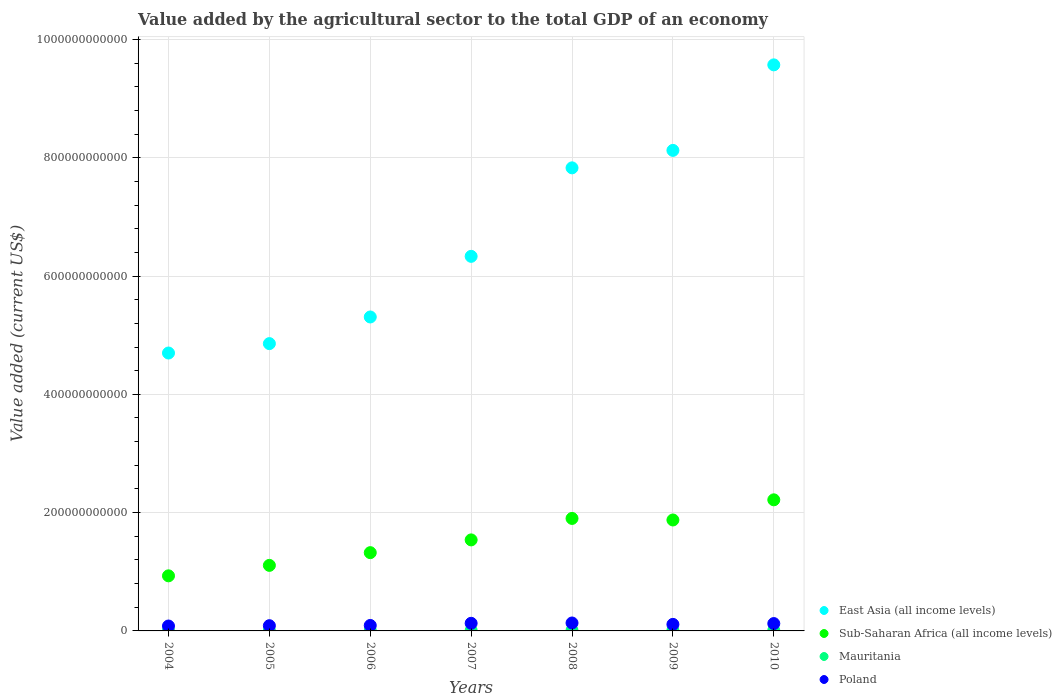Is the number of dotlines equal to the number of legend labels?
Offer a very short reply. Yes. What is the value added by the agricultural sector to the total GDP in Mauritania in 2004?
Give a very brief answer. 5.98e+08. Across all years, what is the maximum value added by the agricultural sector to the total GDP in Sub-Saharan Africa (all income levels)?
Offer a terse response. 2.22e+11. Across all years, what is the minimum value added by the agricultural sector to the total GDP in Mauritania?
Provide a succinct answer. 5.98e+08. In which year was the value added by the agricultural sector to the total GDP in Mauritania minimum?
Offer a terse response. 2004. What is the total value added by the agricultural sector to the total GDP in Sub-Saharan Africa (all income levels) in the graph?
Keep it short and to the point. 1.09e+12. What is the difference between the value added by the agricultural sector to the total GDP in Sub-Saharan Africa (all income levels) in 2008 and that in 2010?
Keep it short and to the point. -3.14e+1. What is the difference between the value added by the agricultural sector to the total GDP in Poland in 2004 and the value added by the agricultural sector to the total GDP in East Asia (all income levels) in 2007?
Provide a short and direct response. -6.25e+11. What is the average value added by the agricultural sector to the total GDP in Poland per year?
Your answer should be compact. 1.09e+1. In the year 2004, what is the difference between the value added by the agricultural sector to the total GDP in Mauritania and value added by the agricultural sector to the total GDP in Poland?
Provide a succinct answer. -7.69e+09. In how many years, is the value added by the agricultural sector to the total GDP in Sub-Saharan Africa (all income levels) greater than 240000000000 US$?
Provide a succinct answer. 0. What is the ratio of the value added by the agricultural sector to the total GDP in Mauritania in 2007 to that in 2010?
Your answer should be very brief. 0.9. Is the difference between the value added by the agricultural sector to the total GDP in Mauritania in 2005 and 2009 greater than the difference between the value added by the agricultural sector to the total GDP in Poland in 2005 and 2009?
Offer a very short reply. Yes. What is the difference between the highest and the second highest value added by the agricultural sector to the total GDP in East Asia (all income levels)?
Keep it short and to the point. 1.45e+11. What is the difference between the highest and the lowest value added by the agricultural sector to the total GDP in Poland?
Give a very brief answer. 5.12e+09. In how many years, is the value added by the agricultural sector to the total GDP in Poland greater than the average value added by the agricultural sector to the total GDP in Poland taken over all years?
Keep it short and to the point. 4. Is the sum of the value added by the agricultural sector to the total GDP in Mauritania in 2005 and 2006 greater than the maximum value added by the agricultural sector to the total GDP in Sub-Saharan Africa (all income levels) across all years?
Your response must be concise. No. Does the value added by the agricultural sector to the total GDP in Mauritania monotonically increase over the years?
Your answer should be compact. No. How many years are there in the graph?
Your answer should be compact. 7. What is the difference between two consecutive major ticks on the Y-axis?
Offer a very short reply. 2.00e+11. Does the graph contain any zero values?
Provide a succinct answer. No. Does the graph contain grids?
Your answer should be very brief. Yes. Where does the legend appear in the graph?
Ensure brevity in your answer.  Bottom right. How many legend labels are there?
Your answer should be compact. 4. How are the legend labels stacked?
Make the answer very short. Vertical. What is the title of the graph?
Your answer should be very brief. Value added by the agricultural sector to the total GDP of an economy. What is the label or title of the X-axis?
Your answer should be compact. Years. What is the label or title of the Y-axis?
Your answer should be very brief. Value added (current US$). What is the Value added (current US$) of East Asia (all income levels) in 2004?
Your response must be concise. 4.70e+11. What is the Value added (current US$) in Sub-Saharan Africa (all income levels) in 2004?
Make the answer very short. 9.31e+1. What is the Value added (current US$) in Mauritania in 2004?
Your answer should be compact. 5.98e+08. What is the Value added (current US$) in Poland in 2004?
Provide a succinct answer. 8.29e+09. What is the Value added (current US$) in East Asia (all income levels) in 2005?
Provide a short and direct response. 4.86e+11. What is the Value added (current US$) in Sub-Saharan Africa (all income levels) in 2005?
Offer a terse response. 1.11e+11. What is the Value added (current US$) in Mauritania in 2005?
Your answer should be compact. 6.15e+08. What is the Value added (current US$) of Poland in 2005?
Your response must be concise. 8.85e+09. What is the Value added (current US$) in East Asia (all income levels) in 2006?
Provide a succinct answer. 5.31e+11. What is the Value added (current US$) of Sub-Saharan Africa (all income levels) in 2006?
Your answer should be compact. 1.32e+11. What is the Value added (current US$) in Mauritania in 2006?
Provide a succinct answer. 6.51e+08. What is the Value added (current US$) in Poland in 2006?
Ensure brevity in your answer.  9.23e+09. What is the Value added (current US$) in East Asia (all income levels) in 2007?
Your answer should be compact. 6.33e+11. What is the Value added (current US$) in Sub-Saharan Africa (all income levels) in 2007?
Your response must be concise. 1.54e+11. What is the Value added (current US$) in Mauritania in 2007?
Your answer should be very brief. 7.93e+08. What is the Value added (current US$) in Poland in 2007?
Offer a very short reply. 1.29e+1. What is the Value added (current US$) in East Asia (all income levels) in 2008?
Give a very brief answer. 7.83e+11. What is the Value added (current US$) of Sub-Saharan Africa (all income levels) in 2008?
Offer a terse response. 1.90e+11. What is the Value added (current US$) of Mauritania in 2008?
Your answer should be compact. 9.45e+08. What is the Value added (current US$) of Poland in 2008?
Keep it short and to the point. 1.34e+1. What is the Value added (current US$) of East Asia (all income levels) in 2009?
Keep it short and to the point. 8.12e+11. What is the Value added (current US$) of Sub-Saharan Africa (all income levels) in 2009?
Ensure brevity in your answer.  1.88e+11. What is the Value added (current US$) of Mauritania in 2009?
Your response must be concise. 8.83e+08. What is the Value added (current US$) of Poland in 2009?
Offer a very short reply. 1.11e+1. What is the Value added (current US$) of East Asia (all income levels) in 2010?
Give a very brief answer. 9.57e+11. What is the Value added (current US$) of Sub-Saharan Africa (all income levels) in 2010?
Keep it short and to the point. 2.22e+11. What is the Value added (current US$) of Mauritania in 2010?
Your answer should be compact. 8.80e+08. What is the Value added (current US$) of Poland in 2010?
Offer a terse response. 1.24e+1. Across all years, what is the maximum Value added (current US$) in East Asia (all income levels)?
Give a very brief answer. 9.57e+11. Across all years, what is the maximum Value added (current US$) of Sub-Saharan Africa (all income levels)?
Give a very brief answer. 2.22e+11. Across all years, what is the maximum Value added (current US$) in Mauritania?
Give a very brief answer. 9.45e+08. Across all years, what is the maximum Value added (current US$) of Poland?
Give a very brief answer. 1.34e+1. Across all years, what is the minimum Value added (current US$) in East Asia (all income levels)?
Make the answer very short. 4.70e+11. Across all years, what is the minimum Value added (current US$) of Sub-Saharan Africa (all income levels)?
Your response must be concise. 9.31e+1. Across all years, what is the minimum Value added (current US$) in Mauritania?
Offer a very short reply. 5.98e+08. Across all years, what is the minimum Value added (current US$) of Poland?
Give a very brief answer. 8.29e+09. What is the total Value added (current US$) in East Asia (all income levels) in the graph?
Offer a terse response. 4.67e+12. What is the total Value added (current US$) in Sub-Saharan Africa (all income levels) in the graph?
Your answer should be compact. 1.09e+12. What is the total Value added (current US$) of Mauritania in the graph?
Make the answer very short. 5.37e+09. What is the total Value added (current US$) in Poland in the graph?
Make the answer very short. 7.62e+1. What is the difference between the Value added (current US$) in East Asia (all income levels) in 2004 and that in 2005?
Make the answer very short. -1.59e+1. What is the difference between the Value added (current US$) of Sub-Saharan Africa (all income levels) in 2004 and that in 2005?
Make the answer very short. -1.77e+1. What is the difference between the Value added (current US$) in Mauritania in 2004 and that in 2005?
Your response must be concise. -1.72e+07. What is the difference between the Value added (current US$) of Poland in 2004 and that in 2005?
Offer a terse response. -5.58e+08. What is the difference between the Value added (current US$) of East Asia (all income levels) in 2004 and that in 2006?
Provide a succinct answer. -6.09e+1. What is the difference between the Value added (current US$) of Sub-Saharan Africa (all income levels) in 2004 and that in 2006?
Provide a short and direct response. -3.92e+1. What is the difference between the Value added (current US$) in Mauritania in 2004 and that in 2006?
Your answer should be very brief. -5.31e+07. What is the difference between the Value added (current US$) in Poland in 2004 and that in 2006?
Give a very brief answer. -9.44e+08. What is the difference between the Value added (current US$) of East Asia (all income levels) in 2004 and that in 2007?
Your answer should be compact. -1.63e+11. What is the difference between the Value added (current US$) in Sub-Saharan Africa (all income levels) in 2004 and that in 2007?
Your response must be concise. -6.08e+1. What is the difference between the Value added (current US$) in Mauritania in 2004 and that in 2007?
Keep it short and to the point. -1.95e+08. What is the difference between the Value added (current US$) in Poland in 2004 and that in 2007?
Provide a short and direct response. -4.59e+09. What is the difference between the Value added (current US$) in East Asia (all income levels) in 2004 and that in 2008?
Your response must be concise. -3.13e+11. What is the difference between the Value added (current US$) of Sub-Saharan Africa (all income levels) in 2004 and that in 2008?
Ensure brevity in your answer.  -9.71e+1. What is the difference between the Value added (current US$) in Mauritania in 2004 and that in 2008?
Your response must be concise. -3.47e+08. What is the difference between the Value added (current US$) of Poland in 2004 and that in 2008?
Provide a short and direct response. -5.12e+09. What is the difference between the Value added (current US$) of East Asia (all income levels) in 2004 and that in 2009?
Your answer should be very brief. -3.43e+11. What is the difference between the Value added (current US$) of Sub-Saharan Africa (all income levels) in 2004 and that in 2009?
Keep it short and to the point. -9.44e+1. What is the difference between the Value added (current US$) of Mauritania in 2004 and that in 2009?
Give a very brief answer. -2.85e+08. What is the difference between the Value added (current US$) of Poland in 2004 and that in 2009?
Your answer should be compact. -2.77e+09. What is the difference between the Value added (current US$) in East Asia (all income levels) in 2004 and that in 2010?
Make the answer very short. -4.87e+11. What is the difference between the Value added (current US$) in Sub-Saharan Africa (all income levels) in 2004 and that in 2010?
Your answer should be compact. -1.29e+11. What is the difference between the Value added (current US$) of Mauritania in 2004 and that in 2010?
Your response must be concise. -2.82e+08. What is the difference between the Value added (current US$) of Poland in 2004 and that in 2010?
Offer a very short reply. -4.15e+09. What is the difference between the Value added (current US$) in East Asia (all income levels) in 2005 and that in 2006?
Make the answer very short. -4.50e+1. What is the difference between the Value added (current US$) in Sub-Saharan Africa (all income levels) in 2005 and that in 2006?
Your answer should be compact. -2.15e+1. What is the difference between the Value added (current US$) in Mauritania in 2005 and that in 2006?
Make the answer very short. -3.58e+07. What is the difference between the Value added (current US$) of Poland in 2005 and that in 2006?
Make the answer very short. -3.87e+08. What is the difference between the Value added (current US$) in East Asia (all income levels) in 2005 and that in 2007?
Keep it short and to the point. -1.48e+11. What is the difference between the Value added (current US$) in Sub-Saharan Africa (all income levels) in 2005 and that in 2007?
Give a very brief answer. -4.31e+1. What is the difference between the Value added (current US$) in Mauritania in 2005 and that in 2007?
Keep it short and to the point. -1.77e+08. What is the difference between the Value added (current US$) of Poland in 2005 and that in 2007?
Offer a terse response. -4.04e+09. What is the difference between the Value added (current US$) in East Asia (all income levels) in 2005 and that in 2008?
Offer a very short reply. -2.97e+11. What is the difference between the Value added (current US$) in Sub-Saharan Africa (all income levels) in 2005 and that in 2008?
Provide a succinct answer. -7.94e+1. What is the difference between the Value added (current US$) of Mauritania in 2005 and that in 2008?
Offer a terse response. -3.29e+08. What is the difference between the Value added (current US$) in Poland in 2005 and that in 2008?
Ensure brevity in your answer.  -4.56e+09. What is the difference between the Value added (current US$) in East Asia (all income levels) in 2005 and that in 2009?
Keep it short and to the point. -3.27e+11. What is the difference between the Value added (current US$) of Sub-Saharan Africa (all income levels) in 2005 and that in 2009?
Your response must be concise. -7.68e+1. What is the difference between the Value added (current US$) in Mauritania in 2005 and that in 2009?
Ensure brevity in your answer.  -2.68e+08. What is the difference between the Value added (current US$) in Poland in 2005 and that in 2009?
Your answer should be compact. -2.21e+09. What is the difference between the Value added (current US$) of East Asia (all income levels) in 2005 and that in 2010?
Your answer should be very brief. -4.71e+11. What is the difference between the Value added (current US$) of Sub-Saharan Africa (all income levels) in 2005 and that in 2010?
Offer a terse response. -1.11e+11. What is the difference between the Value added (current US$) in Mauritania in 2005 and that in 2010?
Your response must be concise. -2.65e+08. What is the difference between the Value added (current US$) in Poland in 2005 and that in 2010?
Provide a short and direct response. -3.60e+09. What is the difference between the Value added (current US$) in East Asia (all income levels) in 2006 and that in 2007?
Offer a terse response. -1.03e+11. What is the difference between the Value added (current US$) in Sub-Saharan Africa (all income levels) in 2006 and that in 2007?
Ensure brevity in your answer.  -2.16e+1. What is the difference between the Value added (current US$) of Mauritania in 2006 and that in 2007?
Offer a terse response. -1.42e+08. What is the difference between the Value added (current US$) of Poland in 2006 and that in 2007?
Keep it short and to the point. -3.65e+09. What is the difference between the Value added (current US$) of East Asia (all income levels) in 2006 and that in 2008?
Your response must be concise. -2.52e+11. What is the difference between the Value added (current US$) of Sub-Saharan Africa (all income levels) in 2006 and that in 2008?
Provide a short and direct response. -5.79e+1. What is the difference between the Value added (current US$) of Mauritania in 2006 and that in 2008?
Offer a very short reply. -2.94e+08. What is the difference between the Value added (current US$) in Poland in 2006 and that in 2008?
Offer a terse response. -4.17e+09. What is the difference between the Value added (current US$) of East Asia (all income levels) in 2006 and that in 2009?
Provide a short and direct response. -2.82e+11. What is the difference between the Value added (current US$) in Sub-Saharan Africa (all income levels) in 2006 and that in 2009?
Provide a short and direct response. -5.52e+1. What is the difference between the Value added (current US$) in Mauritania in 2006 and that in 2009?
Offer a very short reply. -2.32e+08. What is the difference between the Value added (current US$) in Poland in 2006 and that in 2009?
Provide a succinct answer. -1.83e+09. What is the difference between the Value added (current US$) of East Asia (all income levels) in 2006 and that in 2010?
Offer a terse response. -4.26e+11. What is the difference between the Value added (current US$) in Sub-Saharan Africa (all income levels) in 2006 and that in 2010?
Offer a very short reply. -8.93e+1. What is the difference between the Value added (current US$) in Mauritania in 2006 and that in 2010?
Provide a succinct answer. -2.29e+08. What is the difference between the Value added (current US$) in Poland in 2006 and that in 2010?
Make the answer very short. -3.21e+09. What is the difference between the Value added (current US$) in East Asia (all income levels) in 2007 and that in 2008?
Offer a terse response. -1.50e+11. What is the difference between the Value added (current US$) of Sub-Saharan Africa (all income levels) in 2007 and that in 2008?
Offer a very short reply. -3.63e+1. What is the difference between the Value added (current US$) of Mauritania in 2007 and that in 2008?
Your answer should be compact. -1.52e+08. What is the difference between the Value added (current US$) of Poland in 2007 and that in 2008?
Provide a succinct answer. -5.25e+08. What is the difference between the Value added (current US$) in East Asia (all income levels) in 2007 and that in 2009?
Ensure brevity in your answer.  -1.79e+11. What is the difference between the Value added (current US$) of Sub-Saharan Africa (all income levels) in 2007 and that in 2009?
Offer a very short reply. -3.37e+1. What is the difference between the Value added (current US$) in Mauritania in 2007 and that in 2009?
Provide a short and direct response. -9.02e+07. What is the difference between the Value added (current US$) of Poland in 2007 and that in 2009?
Your response must be concise. 1.82e+09. What is the difference between the Value added (current US$) in East Asia (all income levels) in 2007 and that in 2010?
Keep it short and to the point. -3.24e+11. What is the difference between the Value added (current US$) of Sub-Saharan Africa (all income levels) in 2007 and that in 2010?
Your response must be concise. -6.77e+1. What is the difference between the Value added (current US$) in Mauritania in 2007 and that in 2010?
Offer a very short reply. -8.75e+07. What is the difference between the Value added (current US$) in Poland in 2007 and that in 2010?
Make the answer very short. 4.42e+08. What is the difference between the Value added (current US$) in East Asia (all income levels) in 2008 and that in 2009?
Ensure brevity in your answer.  -2.95e+1. What is the difference between the Value added (current US$) in Sub-Saharan Africa (all income levels) in 2008 and that in 2009?
Keep it short and to the point. 2.62e+09. What is the difference between the Value added (current US$) in Mauritania in 2008 and that in 2009?
Offer a terse response. 6.18e+07. What is the difference between the Value added (current US$) of Poland in 2008 and that in 2009?
Provide a short and direct response. 2.35e+09. What is the difference between the Value added (current US$) in East Asia (all income levels) in 2008 and that in 2010?
Keep it short and to the point. -1.74e+11. What is the difference between the Value added (current US$) in Sub-Saharan Africa (all income levels) in 2008 and that in 2010?
Provide a succinct answer. -3.14e+1. What is the difference between the Value added (current US$) in Mauritania in 2008 and that in 2010?
Offer a very short reply. 6.45e+07. What is the difference between the Value added (current US$) of Poland in 2008 and that in 2010?
Give a very brief answer. 9.66e+08. What is the difference between the Value added (current US$) of East Asia (all income levels) in 2009 and that in 2010?
Your response must be concise. -1.45e+11. What is the difference between the Value added (current US$) of Sub-Saharan Africa (all income levels) in 2009 and that in 2010?
Your answer should be compact. -3.41e+1. What is the difference between the Value added (current US$) in Mauritania in 2009 and that in 2010?
Your answer should be very brief. 2.76e+06. What is the difference between the Value added (current US$) of Poland in 2009 and that in 2010?
Offer a very short reply. -1.38e+09. What is the difference between the Value added (current US$) in East Asia (all income levels) in 2004 and the Value added (current US$) in Sub-Saharan Africa (all income levels) in 2005?
Offer a very short reply. 3.59e+11. What is the difference between the Value added (current US$) in East Asia (all income levels) in 2004 and the Value added (current US$) in Mauritania in 2005?
Offer a very short reply. 4.69e+11. What is the difference between the Value added (current US$) of East Asia (all income levels) in 2004 and the Value added (current US$) of Poland in 2005?
Make the answer very short. 4.61e+11. What is the difference between the Value added (current US$) of Sub-Saharan Africa (all income levels) in 2004 and the Value added (current US$) of Mauritania in 2005?
Provide a succinct answer. 9.25e+1. What is the difference between the Value added (current US$) in Sub-Saharan Africa (all income levels) in 2004 and the Value added (current US$) in Poland in 2005?
Offer a very short reply. 8.43e+1. What is the difference between the Value added (current US$) of Mauritania in 2004 and the Value added (current US$) of Poland in 2005?
Offer a very short reply. -8.25e+09. What is the difference between the Value added (current US$) in East Asia (all income levels) in 2004 and the Value added (current US$) in Sub-Saharan Africa (all income levels) in 2006?
Offer a very short reply. 3.38e+11. What is the difference between the Value added (current US$) of East Asia (all income levels) in 2004 and the Value added (current US$) of Mauritania in 2006?
Make the answer very short. 4.69e+11. What is the difference between the Value added (current US$) of East Asia (all income levels) in 2004 and the Value added (current US$) of Poland in 2006?
Your answer should be compact. 4.61e+11. What is the difference between the Value added (current US$) of Sub-Saharan Africa (all income levels) in 2004 and the Value added (current US$) of Mauritania in 2006?
Your answer should be very brief. 9.25e+1. What is the difference between the Value added (current US$) in Sub-Saharan Africa (all income levels) in 2004 and the Value added (current US$) in Poland in 2006?
Give a very brief answer. 8.39e+1. What is the difference between the Value added (current US$) in Mauritania in 2004 and the Value added (current US$) in Poland in 2006?
Your answer should be compact. -8.64e+09. What is the difference between the Value added (current US$) in East Asia (all income levels) in 2004 and the Value added (current US$) in Sub-Saharan Africa (all income levels) in 2007?
Provide a succinct answer. 3.16e+11. What is the difference between the Value added (current US$) of East Asia (all income levels) in 2004 and the Value added (current US$) of Mauritania in 2007?
Offer a terse response. 4.69e+11. What is the difference between the Value added (current US$) of East Asia (all income levels) in 2004 and the Value added (current US$) of Poland in 2007?
Offer a terse response. 4.57e+11. What is the difference between the Value added (current US$) of Sub-Saharan Africa (all income levels) in 2004 and the Value added (current US$) of Mauritania in 2007?
Your response must be concise. 9.23e+1. What is the difference between the Value added (current US$) of Sub-Saharan Africa (all income levels) in 2004 and the Value added (current US$) of Poland in 2007?
Your answer should be compact. 8.03e+1. What is the difference between the Value added (current US$) of Mauritania in 2004 and the Value added (current US$) of Poland in 2007?
Provide a short and direct response. -1.23e+1. What is the difference between the Value added (current US$) in East Asia (all income levels) in 2004 and the Value added (current US$) in Sub-Saharan Africa (all income levels) in 2008?
Your answer should be very brief. 2.80e+11. What is the difference between the Value added (current US$) in East Asia (all income levels) in 2004 and the Value added (current US$) in Mauritania in 2008?
Your answer should be compact. 4.69e+11. What is the difference between the Value added (current US$) in East Asia (all income levels) in 2004 and the Value added (current US$) in Poland in 2008?
Your answer should be very brief. 4.56e+11. What is the difference between the Value added (current US$) in Sub-Saharan Africa (all income levels) in 2004 and the Value added (current US$) in Mauritania in 2008?
Provide a succinct answer. 9.22e+1. What is the difference between the Value added (current US$) of Sub-Saharan Africa (all income levels) in 2004 and the Value added (current US$) of Poland in 2008?
Make the answer very short. 7.97e+1. What is the difference between the Value added (current US$) of Mauritania in 2004 and the Value added (current US$) of Poland in 2008?
Your answer should be compact. -1.28e+1. What is the difference between the Value added (current US$) of East Asia (all income levels) in 2004 and the Value added (current US$) of Sub-Saharan Africa (all income levels) in 2009?
Provide a short and direct response. 2.82e+11. What is the difference between the Value added (current US$) of East Asia (all income levels) in 2004 and the Value added (current US$) of Mauritania in 2009?
Your answer should be very brief. 4.69e+11. What is the difference between the Value added (current US$) of East Asia (all income levels) in 2004 and the Value added (current US$) of Poland in 2009?
Your response must be concise. 4.59e+11. What is the difference between the Value added (current US$) in Sub-Saharan Africa (all income levels) in 2004 and the Value added (current US$) in Mauritania in 2009?
Keep it short and to the point. 9.23e+1. What is the difference between the Value added (current US$) in Sub-Saharan Africa (all income levels) in 2004 and the Value added (current US$) in Poland in 2009?
Offer a terse response. 8.21e+1. What is the difference between the Value added (current US$) in Mauritania in 2004 and the Value added (current US$) in Poland in 2009?
Make the answer very short. -1.05e+1. What is the difference between the Value added (current US$) of East Asia (all income levels) in 2004 and the Value added (current US$) of Sub-Saharan Africa (all income levels) in 2010?
Give a very brief answer. 2.48e+11. What is the difference between the Value added (current US$) of East Asia (all income levels) in 2004 and the Value added (current US$) of Mauritania in 2010?
Your answer should be compact. 4.69e+11. What is the difference between the Value added (current US$) of East Asia (all income levels) in 2004 and the Value added (current US$) of Poland in 2010?
Keep it short and to the point. 4.57e+11. What is the difference between the Value added (current US$) of Sub-Saharan Africa (all income levels) in 2004 and the Value added (current US$) of Mauritania in 2010?
Your response must be concise. 9.23e+1. What is the difference between the Value added (current US$) of Sub-Saharan Africa (all income levels) in 2004 and the Value added (current US$) of Poland in 2010?
Your answer should be compact. 8.07e+1. What is the difference between the Value added (current US$) of Mauritania in 2004 and the Value added (current US$) of Poland in 2010?
Keep it short and to the point. -1.18e+1. What is the difference between the Value added (current US$) of East Asia (all income levels) in 2005 and the Value added (current US$) of Sub-Saharan Africa (all income levels) in 2006?
Ensure brevity in your answer.  3.53e+11. What is the difference between the Value added (current US$) in East Asia (all income levels) in 2005 and the Value added (current US$) in Mauritania in 2006?
Offer a very short reply. 4.85e+11. What is the difference between the Value added (current US$) in East Asia (all income levels) in 2005 and the Value added (current US$) in Poland in 2006?
Offer a very short reply. 4.77e+11. What is the difference between the Value added (current US$) of Sub-Saharan Africa (all income levels) in 2005 and the Value added (current US$) of Mauritania in 2006?
Give a very brief answer. 1.10e+11. What is the difference between the Value added (current US$) of Sub-Saharan Africa (all income levels) in 2005 and the Value added (current US$) of Poland in 2006?
Make the answer very short. 1.02e+11. What is the difference between the Value added (current US$) of Mauritania in 2005 and the Value added (current US$) of Poland in 2006?
Provide a short and direct response. -8.62e+09. What is the difference between the Value added (current US$) of East Asia (all income levels) in 2005 and the Value added (current US$) of Sub-Saharan Africa (all income levels) in 2007?
Provide a short and direct response. 3.32e+11. What is the difference between the Value added (current US$) of East Asia (all income levels) in 2005 and the Value added (current US$) of Mauritania in 2007?
Provide a succinct answer. 4.85e+11. What is the difference between the Value added (current US$) in East Asia (all income levels) in 2005 and the Value added (current US$) in Poland in 2007?
Provide a short and direct response. 4.73e+11. What is the difference between the Value added (current US$) in Sub-Saharan Africa (all income levels) in 2005 and the Value added (current US$) in Mauritania in 2007?
Your answer should be very brief. 1.10e+11. What is the difference between the Value added (current US$) in Sub-Saharan Africa (all income levels) in 2005 and the Value added (current US$) in Poland in 2007?
Provide a succinct answer. 9.79e+1. What is the difference between the Value added (current US$) of Mauritania in 2005 and the Value added (current US$) of Poland in 2007?
Provide a short and direct response. -1.23e+1. What is the difference between the Value added (current US$) in East Asia (all income levels) in 2005 and the Value added (current US$) in Sub-Saharan Africa (all income levels) in 2008?
Make the answer very short. 2.96e+11. What is the difference between the Value added (current US$) of East Asia (all income levels) in 2005 and the Value added (current US$) of Mauritania in 2008?
Your answer should be very brief. 4.85e+11. What is the difference between the Value added (current US$) of East Asia (all income levels) in 2005 and the Value added (current US$) of Poland in 2008?
Provide a short and direct response. 4.72e+11. What is the difference between the Value added (current US$) of Sub-Saharan Africa (all income levels) in 2005 and the Value added (current US$) of Mauritania in 2008?
Give a very brief answer. 1.10e+11. What is the difference between the Value added (current US$) in Sub-Saharan Africa (all income levels) in 2005 and the Value added (current US$) in Poland in 2008?
Your answer should be very brief. 9.74e+1. What is the difference between the Value added (current US$) in Mauritania in 2005 and the Value added (current US$) in Poland in 2008?
Your answer should be compact. -1.28e+1. What is the difference between the Value added (current US$) in East Asia (all income levels) in 2005 and the Value added (current US$) in Sub-Saharan Africa (all income levels) in 2009?
Offer a very short reply. 2.98e+11. What is the difference between the Value added (current US$) of East Asia (all income levels) in 2005 and the Value added (current US$) of Mauritania in 2009?
Make the answer very short. 4.85e+11. What is the difference between the Value added (current US$) in East Asia (all income levels) in 2005 and the Value added (current US$) in Poland in 2009?
Keep it short and to the point. 4.75e+11. What is the difference between the Value added (current US$) in Sub-Saharan Africa (all income levels) in 2005 and the Value added (current US$) in Mauritania in 2009?
Offer a very short reply. 1.10e+11. What is the difference between the Value added (current US$) in Sub-Saharan Africa (all income levels) in 2005 and the Value added (current US$) in Poland in 2009?
Offer a very short reply. 9.98e+1. What is the difference between the Value added (current US$) of Mauritania in 2005 and the Value added (current US$) of Poland in 2009?
Keep it short and to the point. -1.04e+1. What is the difference between the Value added (current US$) of East Asia (all income levels) in 2005 and the Value added (current US$) of Sub-Saharan Africa (all income levels) in 2010?
Provide a short and direct response. 2.64e+11. What is the difference between the Value added (current US$) of East Asia (all income levels) in 2005 and the Value added (current US$) of Mauritania in 2010?
Offer a very short reply. 4.85e+11. What is the difference between the Value added (current US$) of East Asia (all income levels) in 2005 and the Value added (current US$) of Poland in 2010?
Keep it short and to the point. 4.73e+11. What is the difference between the Value added (current US$) in Sub-Saharan Africa (all income levels) in 2005 and the Value added (current US$) in Mauritania in 2010?
Give a very brief answer. 1.10e+11. What is the difference between the Value added (current US$) in Sub-Saharan Africa (all income levels) in 2005 and the Value added (current US$) in Poland in 2010?
Your answer should be compact. 9.84e+1. What is the difference between the Value added (current US$) in Mauritania in 2005 and the Value added (current US$) in Poland in 2010?
Offer a very short reply. -1.18e+1. What is the difference between the Value added (current US$) in East Asia (all income levels) in 2006 and the Value added (current US$) in Sub-Saharan Africa (all income levels) in 2007?
Your response must be concise. 3.77e+11. What is the difference between the Value added (current US$) in East Asia (all income levels) in 2006 and the Value added (current US$) in Mauritania in 2007?
Offer a very short reply. 5.30e+11. What is the difference between the Value added (current US$) in East Asia (all income levels) in 2006 and the Value added (current US$) in Poland in 2007?
Make the answer very short. 5.18e+11. What is the difference between the Value added (current US$) in Sub-Saharan Africa (all income levels) in 2006 and the Value added (current US$) in Mauritania in 2007?
Your answer should be compact. 1.32e+11. What is the difference between the Value added (current US$) of Sub-Saharan Africa (all income levels) in 2006 and the Value added (current US$) of Poland in 2007?
Provide a succinct answer. 1.19e+11. What is the difference between the Value added (current US$) in Mauritania in 2006 and the Value added (current US$) in Poland in 2007?
Make the answer very short. -1.22e+1. What is the difference between the Value added (current US$) in East Asia (all income levels) in 2006 and the Value added (current US$) in Sub-Saharan Africa (all income levels) in 2008?
Your answer should be very brief. 3.41e+11. What is the difference between the Value added (current US$) of East Asia (all income levels) in 2006 and the Value added (current US$) of Mauritania in 2008?
Keep it short and to the point. 5.30e+11. What is the difference between the Value added (current US$) in East Asia (all income levels) in 2006 and the Value added (current US$) in Poland in 2008?
Your response must be concise. 5.17e+11. What is the difference between the Value added (current US$) of Sub-Saharan Africa (all income levels) in 2006 and the Value added (current US$) of Mauritania in 2008?
Offer a very short reply. 1.31e+11. What is the difference between the Value added (current US$) in Sub-Saharan Africa (all income levels) in 2006 and the Value added (current US$) in Poland in 2008?
Provide a succinct answer. 1.19e+11. What is the difference between the Value added (current US$) of Mauritania in 2006 and the Value added (current US$) of Poland in 2008?
Your response must be concise. -1.28e+1. What is the difference between the Value added (current US$) in East Asia (all income levels) in 2006 and the Value added (current US$) in Sub-Saharan Africa (all income levels) in 2009?
Keep it short and to the point. 3.43e+11. What is the difference between the Value added (current US$) in East Asia (all income levels) in 2006 and the Value added (current US$) in Mauritania in 2009?
Keep it short and to the point. 5.30e+11. What is the difference between the Value added (current US$) of East Asia (all income levels) in 2006 and the Value added (current US$) of Poland in 2009?
Give a very brief answer. 5.20e+11. What is the difference between the Value added (current US$) of Sub-Saharan Africa (all income levels) in 2006 and the Value added (current US$) of Mauritania in 2009?
Make the answer very short. 1.31e+11. What is the difference between the Value added (current US$) in Sub-Saharan Africa (all income levels) in 2006 and the Value added (current US$) in Poland in 2009?
Provide a succinct answer. 1.21e+11. What is the difference between the Value added (current US$) of Mauritania in 2006 and the Value added (current US$) of Poland in 2009?
Your answer should be compact. -1.04e+1. What is the difference between the Value added (current US$) of East Asia (all income levels) in 2006 and the Value added (current US$) of Sub-Saharan Africa (all income levels) in 2010?
Ensure brevity in your answer.  3.09e+11. What is the difference between the Value added (current US$) of East Asia (all income levels) in 2006 and the Value added (current US$) of Mauritania in 2010?
Provide a succinct answer. 5.30e+11. What is the difference between the Value added (current US$) in East Asia (all income levels) in 2006 and the Value added (current US$) in Poland in 2010?
Make the answer very short. 5.18e+11. What is the difference between the Value added (current US$) of Sub-Saharan Africa (all income levels) in 2006 and the Value added (current US$) of Mauritania in 2010?
Your answer should be very brief. 1.31e+11. What is the difference between the Value added (current US$) of Sub-Saharan Africa (all income levels) in 2006 and the Value added (current US$) of Poland in 2010?
Give a very brief answer. 1.20e+11. What is the difference between the Value added (current US$) of Mauritania in 2006 and the Value added (current US$) of Poland in 2010?
Offer a very short reply. -1.18e+1. What is the difference between the Value added (current US$) in East Asia (all income levels) in 2007 and the Value added (current US$) in Sub-Saharan Africa (all income levels) in 2008?
Make the answer very short. 4.43e+11. What is the difference between the Value added (current US$) of East Asia (all income levels) in 2007 and the Value added (current US$) of Mauritania in 2008?
Your response must be concise. 6.32e+11. What is the difference between the Value added (current US$) of East Asia (all income levels) in 2007 and the Value added (current US$) of Poland in 2008?
Ensure brevity in your answer.  6.20e+11. What is the difference between the Value added (current US$) in Sub-Saharan Africa (all income levels) in 2007 and the Value added (current US$) in Mauritania in 2008?
Your answer should be very brief. 1.53e+11. What is the difference between the Value added (current US$) in Sub-Saharan Africa (all income levels) in 2007 and the Value added (current US$) in Poland in 2008?
Make the answer very short. 1.40e+11. What is the difference between the Value added (current US$) in Mauritania in 2007 and the Value added (current US$) in Poland in 2008?
Provide a succinct answer. -1.26e+1. What is the difference between the Value added (current US$) of East Asia (all income levels) in 2007 and the Value added (current US$) of Sub-Saharan Africa (all income levels) in 2009?
Provide a succinct answer. 4.46e+11. What is the difference between the Value added (current US$) in East Asia (all income levels) in 2007 and the Value added (current US$) in Mauritania in 2009?
Make the answer very short. 6.32e+11. What is the difference between the Value added (current US$) in East Asia (all income levels) in 2007 and the Value added (current US$) in Poland in 2009?
Ensure brevity in your answer.  6.22e+11. What is the difference between the Value added (current US$) in Sub-Saharan Africa (all income levels) in 2007 and the Value added (current US$) in Mauritania in 2009?
Offer a very short reply. 1.53e+11. What is the difference between the Value added (current US$) in Sub-Saharan Africa (all income levels) in 2007 and the Value added (current US$) in Poland in 2009?
Your answer should be very brief. 1.43e+11. What is the difference between the Value added (current US$) of Mauritania in 2007 and the Value added (current US$) of Poland in 2009?
Offer a very short reply. -1.03e+1. What is the difference between the Value added (current US$) in East Asia (all income levels) in 2007 and the Value added (current US$) in Sub-Saharan Africa (all income levels) in 2010?
Make the answer very short. 4.12e+11. What is the difference between the Value added (current US$) in East Asia (all income levels) in 2007 and the Value added (current US$) in Mauritania in 2010?
Offer a terse response. 6.32e+11. What is the difference between the Value added (current US$) in East Asia (all income levels) in 2007 and the Value added (current US$) in Poland in 2010?
Provide a succinct answer. 6.21e+11. What is the difference between the Value added (current US$) of Sub-Saharan Africa (all income levels) in 2007 and the Value added (current US$) of Mauritania in 2010?
Offer a terse response. 1.53e+11. What is the difference between the Value added (current US$) of Sub-Saharan Africa (all income levels) in 2007 and the Value added (current US$) of Poland in 2010?
Offer a very short reply. 1.41e+11. What is the difference between the Value added (current US$) in Mauritania in 2007 and the Value added (current US$) in Poland in 2010?
Provide a short and direct response. -1.17e+1. What is the difference between the Value added (current US$) of East Asia (all income levels) in 2008 and the Value added (current US$) of Sub-Saharan Africa (all income levels) in 2009?
Offer a very short reply. 5.95e+11. What is the difference between the Value added (current US$) in East Asia (all income levels) in 2008 and the Value added (current US$) in Mauritania in 2009?
Offer a terse response. 7.82e+11. What is the difference between the Value added (current US$) of East Asia (all income levels) in 2008 and the Value added (current US$) of Poland in 2009?
Offer a very short reply. 7.72e+11. What is the difference between the Value added (current US$) of Sub-Saharan Africa (all income levels) in 2008 and the Value added (current US$) of Mauritania in 2009?
Your answer should be very brief. 1.89e+11. What is the difference between the Value added (current US$) in Sub-Saharan Africa (all income levels) in 2008 and the Value added (current US$) in Poland in 2009?
Offer a terse response. 1.79e+11. What is the difference between the Value added (current US$) of Mauritania in 2008 and the Value added (current US$) of Poland in 2009?
Provide a short and direct response. -1.01e+1. What is the difference between the Value added (current US$) of East Asia (all income levels) in 2008 and the Value added (current US$) of Sub-Saharan Africa (all income levels) in 2010?
Offer a terse response. 5.61e+11. What is the difference between the Value added (current US$) in East Asia (all income levels) in 2008 and the Value added (current US$) in Mauritania in 2010?
Give a very brief answer. 7.82e+11. What is the difference between the Value added (current US$) in East Asia (all income levels) in 2008 and the Value added (current US$) in Poland in 2010?
Offer a terse response. 7.70e+11. What is the difference between the Value added (current US$) in Sub-Saharan Africa (all income levels) in 2008 and the Value added (current US$) in Mauritania in 2010?
Offer a very short reply. 1.89e+11. What is the difference between the Value added (current US$) in Sub-Saharan Africa (all income levels) in 2008 and the Value added (current US$) in Poland in 2010?
Provide a succinct answer. 1.78e+11. What is the difference between the Value added (current US$) of Mauritania in 2008 and the Value added (current US$) of Poland in 2010?
Your response must be concise. -1.15e+1. What is the difference between the Value added (current US$) of East Asia (all income levels) in 2009 and the Value added (current US$) of Sub-Saharan Africa (all income levels) in 2010?
Offer a very short reply. 5.91e+11. What is the difference between the Value added (current US$) of East Asia (all income levels) in 2009 and the Value added (current US$) of Mauritania in 2010?
Offer a terse response. 8.12e+11. What is the difference between the Value added (current US$) of East Asia (all income levels) in 2009 and the Value added (current US$) of Poland in 2010?
Make the answer very short. 8.00e+11. What is the difference between the Value added (current US$) of Sub-Saharan Africa (all income levels) in 2009 and the Value added (current US$) of Mauritania in 2010?
Provide a short and direct response. 1.87e+11. What is the difference between the Value added (current US$) of Sub-Saharan Africa (all income levels) in 2009 and the Value added (current US$) of Poland in 2010?
Give a very brief answer. 1.75e+11. What is the difference between the Value added (current US$) in Mauritania in 2009 and the Value added (current US$) in Poland in 2010?
Provide a succinct answer. -1.16e+1. What is the average Value added (current US$) of East Asia (all income levels) per year?
Provide a succinct answer. 6.67e+11. What is the average Value added (current US$) of Sub-Saharan Africa (all income levels) per year?
Keep it short and to the point. 1.56e+11. What is the average Value added (current US$) of Mauritania per year?
Your answer should be compact. 7.67e+08. What is the average Value added (current US$) of Poland per year?
Offer a very short reply. 1.09e+1. In the year 2004, what is the difference between the Value added (current US$) of East Asia (all income levels) and Value added (current US$) of Sub-Saharan Africa (all income levels)?
Offer a terse response. 3.77e+11. In the year 2004, what is the difference between the Value added (current US$) in East Asia (all income levels) and Value added (current US$) in Mauritania?
Ensure brevity in your answer.  4.69e+11. In the year 2004, what is the difference between the Value added (current US$) of East Asia (all income levels) and Value added (current US$) of Poland?
Ensure brevity in your answer.  4.62e+11. In the year 2004, what is the difference between the Value added (current US$) of Sub-Saharan Africa (all income levels) and Value added (current US$) of Mauritania?
Offer a very short reply. 9.25e+1. In the year 2004, what is the difference between the Value added (current US$) of Sub-Saharan Africa (all income levels) and Value added (current US$) of Poland?
Provide a short and direct response. 8.48e+1. In the year 2004, what is the difference between the Value added (current US$) of Mauritania and Value added (current US$) of Poland?
Make the answer very short. -7.69e+09. In the year 2005, what is the difference between the Value added (current US$) of East Asia (all income levels) and Value added (current US$) of Sub-Saharan Africa (all income levels)?
Make the answer very short. 3.75e+11. In the year 2005, what is the difference between the Value added (current US$) in East Asia (all income levels) and Value added (current US$) in Mauritania?
Your response must be concise. 4.85e+11. In the year 2005, what is the difference between the Value added (current US$) of East Asia (all income levels) and Value added (current US$) of Poland?
Keep it short and to the point. 4.77e+11. In the year 2005, what is the difference between the Value added (current US$) of Sub-Saharan Africa (all income levels) and Value added (current US$) of Mauritania?
Keep it short and to the point. 1.10e+11. In the year 2005, what is the difference between the Value added (current US$) in Sub-Saharan Africa (all income levels) and Value added (current US$) in Poland?
Provide a succinct answer. 1.02e+11. In the year 2005, what is the difference between the Value added (current US$) of Mauritania and Value added (current US$) of Poland?
Give a very brief answer. -8.23e+09. In the year 2006, what is the difference between the Value added (current US$) of East Asia (all income levels) and Value added (current US$) of Sub-Saharan Africa (all income levels)?
Make the answer very short. 3.98e+11. In the year 2006, what is the difference between the Value added (current US$) of East Asia (all income levels) and Value added (current US$) of Mauritania?
Your response must be concise. 5.30e+11. In the year 2006, what is the difference between the Value added (current US$) of East Asia (all income levels) and Value added (current US$) of Poland?
Keep it short and to the point. 5.22e+11. In the year 2006, what is the difference between the Value added (current US$) of Sub-Saharan Africa (all income levels) and Value added (current US$) of Mauritania?
Ensure brevity in your answer.  1.32e+11. In the year 2006, what is the difference between the Value added (current US$) of Sub-Saharan Africa (all income levels) and Value added (current US$) of Poland?
Offer a very short reply. 1.23e+11. In the year 2006, what is the difference between the Value added (current US$) of Mauritania and Value added (current US$) of Poland?
Provide a succinct answer. -8.58e+09. In the year 2007, what is the difference between the Value added (current US$) of East Asia (all income levels) and Value added (current US$) of Sub-Saharan Africa (all income levels)?
Provide a short and direct response. 4.79e+11. In the year 2007, what is the difference between the Value added (current US$) in East Asia (all income levels) and Value added (current US$) in Mauritania?
Make the answer very short. 6.33e+11. In the year 2007, what is the difference between the Value added (current US$) of East Asia (all income levels) and Value added (current US$) of Poland?
Offer a very short reply. 6.20e+11. In the year 2007, what is the difference between the Value added (current US$) of Sub-Saharan Africa (all income levels) and Value added (current US$) of Mauritania?
Keep it short and to the point. 1.53e+11. In the year 2007, what is the difference between the Value added (current US$) in Sub-Saharan Africa (all income levels) and Value added (current US$) in Poland?
Give a very brief answer. 1.41e+11. In the year 2007, what is the difference between the Value added (current US$) in Mauritania and Value added (current US$) in Poland?
Keep it short and to the point. -1.21e+1. In the year 2008, what is the difference between the Value added (current US$) in East Asia (all income levels) and Value added (current US$) in Sub-Saharan Africa (all income levels)?
Offer a terse response. 5.93e+11. In the year 2008, what is the difference between the Value added (current US$) in East Asia (all income levels) and Value added (current US$) in Mauritania?
Your answer should be compact. 7.82e+11. In the year 2008, what is the difference between the Value added (current US$) of East Asia (all income levels) and Value added (current US$) of Poland?
Ensure brevity in your answer.  7.70e+11. In the year 2008, what is the difference between the Value added (current US$) in Sub-Saharan Africa (all income levels) and Value added (current US$) in Mauritania?
Offer a terse response. 1.89e+11. In the year 2008, what is the difference between the Value added (current US$) of Sub-Saharan Africa (all income levels) and Value added (current US$) of Poland?
Offer a very short reply. 1.77e+11. In the year 2008, what is the difference between the Value added (current US$) in Mauritania and Value added (current US$) in Poland?
Offer a very short reply. -1.25e+1. In the year 2009, what is the difference between the Value added (current US$) of East Asia (all income levels) and Value added (current US$) of Sub-Saharan Africa (all income levels)?
Provide a succinct answer. 6.25e+11. In the year 2009, what is the difference between the Value added (current US$) of East Asia (all income levels) and Value added (current US$) of Mauritania?
Make the answer very short. 8.12e+11. In the year 2009, what is the difference between the Value added (current US$) of East Asia (all income levels) and Value added (current US$) of Poland?
Make the answer very short. 8.01e+11. In the year 2009, what is the difference between the Value added (current US$) of Sub-Saharan Africa (all income levels) and Value added (current US$) of Mauritania?
Provide a short and direct response. 1.87e+11. In the year 2009, what is the difference between the Value added (current US$) of Sub-Saharan Africa (all income levels) and Value added (current US$) of Poland?
Offer a terse response. 1.77e+11. In the year 2009, what is the difference between the Value added (current US$) of Mauritania and Value added (current US$) of Poland?
Your response must be concise. -1.02e+1. In the year 2010, what is the difference between the Value added (current US$) of East Asia (all income levels) and Value added (current US$) of Sub-Saharan Africa (all income levels)?
Give a very brief answer. 7.35e+11. In the year 2010, what is the difference between the Value added (current US$) of East Asia (all income levels) and Value added (current US$) of Mauritania?
Your answer should be compact. 9.56e+11. In the year 2010, what is the difference between the Value added (current US$) in East Asia (all income levels) and Value added (current US$) in Poland?
Provide a short and direct response. 9.45e+11. In the year 2010, what is the difference between the Value added (current US$) of Sub-Saharan Africa (all income levels) and Value added (current US$) of Mauritania?
Provide a succinct answer. 2.21e+11. In the year 2010, what is the difference between the Value added (current US$) in Sub-Saharan Africa (all income levels) and Value added (current US$) in Poland?
Your response must be concise. 2.09e+11. In the year 2010, what is the difference between the Value added (current US$) of Mauritania and Value added (current US$) of Poland?
Offer a terse response. -1.16e+1. What is the ratio of the Value added (current US$) of East Asia (all income levels) in 2004 to that in 2005?
Your response must be concise. 0.97. What is the ratio of the Value added (current US$) in Sub-Saharan Africa (all income levels) in 2004 to that in 2005?
Your answer should be very brief. 0.84. What is the ratio of the Value added (current US$) of Mauritania in 2004 to that in 2005?
Your answer should be very brief. 0.97. What is the ratio of the Value added (current US$) of Poland in 2004 to that in 2005?
Keep it short and to the point. 0.94. What is the ratio of the Value added (current US$) of East Asia (all income levels) in 2004 to that in 2006?
Ensure brevity in your answer.  0.89. What is the ratio of the Value added (current US$) in Sub-Saharan Africa (all income levels) in 2004 to that in 2006?
Your answer should be compact. 0.7. What is the ratio of the Value added (current US$) in Mauritania in 2004 to that in 2006?
Provide a short and direct response. 0.92. What is the ratio of the Value added (current US$) in Poland in 2004 to that in 2006?
Your response must be concise. 0.9. What is the ratio of the Value added (current US$) of East Asia (all income levels) in 2004 to that in 2007?
Your answer should be very brief. 0.74. What is the ratio of the Value added (current US$) in Sub-Saharan Africa (all income levels) in 2004 to that in 2007?
Keep it short and to the point. 0.61. What is the ratio of the Value added (current US$) in Mauritania in 2004 to that in 2007?
Give a very brief answer. 0.75. What is the ratio of the Value added (current US$) of Poland in 2004 to that in 2007?
Offer a terse response. 0.64. What is the ratio of the Value added (current US$) of East Asia (all income levels) in 2004 to that in 2008?
Offer a very short reply. 0.6. What is the ratio of the Value added (current US$) in Sub-Saharan Africa (all income levels) in 2004 to that in 2008?
Your response must be concise. 0.49. What is the ratio of the Value added (current US$) of Mauritania in 2004 to that in 2008?
Provide a succinct answer. 0.63. What is the ratio of the Value added (current US$) of Poland in 2004 to that in 2008?
Ensure brevity in your answer.  0.62. What is the ratio of the Value added (current US$) of East Asia (all income levels) in 2004 to that in 2009?
Make the answer very short. 0.58. What is the ratio of the Value added (current US$) in Sub-Saharan Africa (all income levels) in 2004 to that in 2009?
Provide a succinct answer. 0.5. What is the ratio of the Value added (current US$) in Mauritania in 2004 to that in 2009?
Make the answer very short. 0.68. What is the ratio of the Value added (current US$) in Poland in 2004 to that in 2009?
Provide a succinct answer. 0.75. What is the ratio of the Value added (current US$) in East Asia (all income levels) in 2004 to that in 2010?
Ensure brevity in your answer.  0.49. What is the ratio of the Value added (current US$) in Sub-Saharan Africa (all income levels) in 2004 to that in 2010?
Provide a short and direct response. 0.42. What is the ratio of the Value added (current US$) in Mauritania in 2004 to that in 2010?
Your answer should be compact. 0.68. What is the ratio of the Value added (current US$) of Poland in 2004 to that in 2010?
Offer a terse response. 0.67. What is the ratio of the Value added (current US$) in East Asia (all income levels) in 2005 to that in 2006?
Your response must be concise. 0.92. What is the ratio of the Value added (current US$) in Sub-Saharan Africa (all income levels) in 2005 to that in 2006?
Your response must be concise. 0.84. What is the ratio of the Value added (current US$) of Mauritania in 2005 to that in 2006?
Ensure brevity in your answer.  0.94. What is the ratio of the Value added (current US$) in Poland in 2005 to that in 2006?
Offer a very short reply. 0.96. What is the ratio of the Value added (current US$) of East Asia (all income levels) in 2005 to that in 2007?
Your answer should be very brief. 0.77. What is the ratio of the Value added (current US$) in Sub-Saharan Africa (all income levels) in 2005 to that in 2007?
Provide a succinct answer. 0.72. What is the ratio of the Value added (current US$) of Mauritania in 2005 to that in 2007?
Ensure brevity in your answer.  0.78. What is the ratio of the Value added (current US$) of Poland in 2005 to that in 2007?
Ensure brevity in your answer.  0.69. What is the ratio of the Value added (current US$) of East Asia (all income levels) in 2005 to that in 2008?
Offer a terse response. 0.62. What is the ratio of the Value added (current US$) of Sub-Saharan Africa (all income levels) in 2005 to that in 2008?
Your answer should be very brief. 0.58. What is the ratio of the Value added (current US$) in Mauritania in 2005 to that in 2008?
Provide a short and direct response. 0.65. What is the ratio of the Value added (current US$) in Poland in 2005 to that in 2008?
Make the answer very short. 0.66. What is the ratio of the Value added (current US$) of East Asia (all income levels) in 2005 to that in 2009?
Give a very brief answer. 0.6. What is the ratio of the Value added (current US$) of Sub-Saharan Africa (all income levels) in 2005 to that in 2009?
Provide a succinct answer. 0.59. What is the ratio of the Value added (current US$) of Mauritania in 2005 to that in 2009?
Your response must be concise. 0.7. What is the ratio of the Value added (current US$) in Poland in 2005 to that in 2009?
Provide a succinct answer. 0.8. What is the ratio of the Value added (current US$) in East Asia (all income levels) in 2005 to that in 2010?
Ensure brevity in your answer.  0.51. What is the ratio of the Value added (current US$) in Mauritania in 2005 to that in 2010?
Keep it short and to the point. 0.7. What is the ratio of the Value added (current US$) of Poland in 2005 to that in 2010?
Your answer should be very brief. 0.71. What is the ratio of the Value added (current US$) in East Asia (all income levels) in 2006 to that in 2007?
Your answer should be very brief. 0.84. What is the ratio of the Value added (current US$) in Sub-Saharan Africa (all income levels) in 2006 to that in 2007?
Give a very brief answer. 0.86. What is the ratio of the Value added (current US$) in Mauritania in 2006 to that in 2007?
Your response must be concise. 0.82. What is the ratio of the Value added (current US$) in Poland in 2006 to that in 2007?
Provide a succinct answer. 0.72. What is the ratio of the Value added (current US$) in East Asia (all income levels) in 2006 to that in 2008?
Your response must be concise. 0.68. What is the ratio of the Value added (current US$) of Sub-Saharan Africa (all income levels) in 2006 to that in 2008?
Provide a succinct answer. 0.7. What is the ratio of the Value added (current US$) in Mauritania in 2006 to that in 2008?
Make the answer very short. 0.69. What is the ratio of the Value added (current US$) of Poland in 2006 to that in 2008?
Offer a terse response. 0.69. What is the ratio of the Value added (current US$) of East Asia (all income levels) in 2006 to that in 2009?
Offer a very short reply. 0.65. What is the ratio of the Value added (current US$) of Sub-Saharan Africa (all income levels) in 2006 to that in 2009?
Provide a short and direct response. 0.71. What is the ratio of the Value added (current US$) of Mauritania in 2006 to that in 2009?
Your response must be concise. 0.74. What is the ratio of the Value added (current US$) of Poland in 2006 to that in 2009?
Offer a very short reply. 0.83. What is the ratio of the Value added (current US$) of East Asia (all income levels) in 2006 to that in 2010?
Ensure brevity in your answer.  0.55. What is the ratio of the Value added (current US$) of Sub-Saharan Africa (all income levels) in 2006 to that in 2010?
Your response must be concise. 0.6. What is the ratio of the Value added (current US$) of Mauritania in 2006 to that in 2010?
Offer a very short reply. 0.74. What is the ratio of the Value added (current US$) in Poland in 2006 to that in 2010?
Keep it short and to the point. 0.74. What is the ratio of the Value added (current US$) of East Asia (all income levels) in 2007 to that in 2008?
Give a very brief answer. 0.81. What is the ratio of the Value added (current US$) in Sub-Saharan Africa (all income levels) in 2007 to that in 2008?
Keep it short and to the point. 0.81. What is the ratio of the Value added (current US$) in Mauritania in 2007 to that in 2008?
Give a very brief answer. 0.84. What is the ratio of the Value added (current US$) of Poland in 2007 to that in 2008?
Give a very brief answer. 0.96. What is the ratio of the Value added (current US$) of East Asia (all income levels) in 2007 to that in 2009?
Your response must be concise. 0.78. What is the ratio of the Value added (current US$) in Sub-Saharan Africa (all income levels) in 2007 to that in 2009?
Keep it short and to the point. 0.82. What is the ratio of the Value added (current US$) of Mauritania in 2007 to that in 2009?
Offer a very short reply. 0.9. What is the ratio of the Value added (current US$) of Poland in 2007 to that in 2009?
Offer a terse response. 1.16. What is the ratio of the Value added (current US$) in East Asia (all income levels) in 2007 to that in 2010?
Your answer should be very brief. 0.66. What is the ratio of the Value added (current US$) of Sub-Saharan Africa (all income levels) in 2007 to that in 2010?
Provide a succinct answer. 0.69. What is the ratio of the Value added (current US$) in Mauritania in 2007 to that in 2010?
Your response must be concise. 0.9. What is the ratio of the Value added (current US$) of Poland in 2007 to that in 2010?
Ensure brevity in your answer.  1.04. What is the ratio of the Value added (current US$) of East Asia (all income levels) in 2008 to that in 2009?
Your answer should be very brief. 0.96. What is the ratio of the Value added (current US$) of Mauritania in 2008 to that in 2009?
Provide a succinct answer. 1.07. What is the ratio of the Value added (current US$) in Poland in 2008 to that in 2009?
Your answer should be very brief. 1.21. What is the ratio of the Value added (current US$) in East Asia (all income levels) in 2008 to that in 2010?
Provide a succinct answer. 0.82. What is the ratio of the Value added (current US$) of Sub-Saharan Africa (all income levels) in 2008 to that in 2010?
Make the answer very short. 0.86. What is the ratio of the Value added (current US$) of Mauritania in 2008 to that in 2010?
Make the answer very short. 1.07. What is the ratio of the Value added (current US$) in Poland in 2008 to that in 2010?
Provide a short and direct response. 1.08. What is the ratio of the Value added (current US$) in East Asia (all income levels) in 2009 to that in 2010?
Make the answer very short. 0.85. What is the ratio of the Value added (current US$) in Sub-Saharan Africa (all income levels) in 2009 to that in 2010?
Make the answer very short. 0.85. What is the ratio of the Value added (current US$) in Poland in 2009 to that in 2010?
Provide a succinct answer. 0.89. What is the difference between the highest and the second highest Value added (current US$) in East Asia (all income levels)?
Offer a terse response. 1.45e+11. What is the difference between the highest and the second highest Value added (current US$) in Sub-Saharan Africa (all income levels)?
Provide a succinct answer. 3.14e+1. What is the difference between the highest and the second highest Value added (current US$) of Mauritania?
Your response must be concise. 6.18e+07. What is the difference between the highest and the second highest Value added (current US$) of Poland?
Keep it short and to the point. 5.25e+08. What is the difference between the highest and the lowest Value added (current US$) of East Asia (all income levels)?
Offer a very short reply. 4.87e+11. What is the difference between the highest and the lowest Value added (current US$) in Sub-Saharan Africa (all income levels)?
Provide a succinct answer. 1.29e+11. What is the difference between the highest and the lowest Value added (current US$) of Mauritania?
Keep it short and to the point. 3.47e+08. What is the difference between the highest and the lowest Value added (current US$) in Poland?
Make the answer very short. 5.12e+09. 